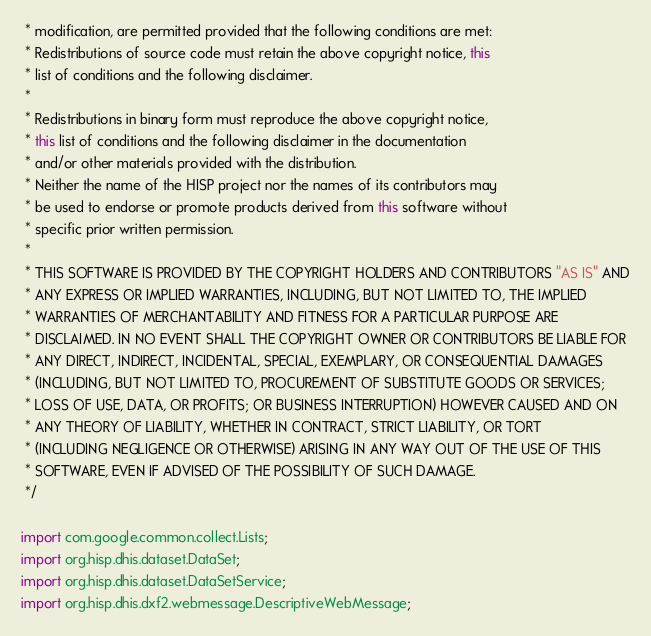<code> <loc_0><loc_0><loc_500><loc_500><_Java_> * modification, are permitted provided that the following conditions are met:
 * Redistributions of source code must retain the above copyright notice, this
 * list of conditions and the following disclaimer.
 *
 * Redistributions in binary form must reproduce the above copyright notice,
 * this list of conditions and the following disclaimer in the documentation
 * and/or other materials provided with the distribution.
 * Neither the name of the HISP project nor the names of its contributors may
 * be used to endorse or promote products derived from this software without
 * specific prior written permission.
 *
 * THIS SOFTWARE IS PROVIDED BY THE COPYRIGHT HOLDERS AND CONTRIBUTORS "AS IS" AND
 * ANY EXPRESS OR IMPLIED WARRANTIES, INCLUDING, BUT NOT LIMITED TO, THE IMPLIED
 * WARRANTIES OF MERCHANTABILITY AND FITNESS FOR A PARTICULAR PURPOSE ARE
 * DISCLAIMED. IN NO EVENT SHALL THE COPYRIGHT OWNER OR CONTRIBUTORS BE LIABLE FOR
 * ANY DIRECT, INDIRECT, INCIDENTAL, SPECIAL, EXEMPLARY, OR CONSEQUENTIAL DAMAGES
 * (INCLUDING, BUT NOT LIMITED TO, PROCUREMENT OF SUBSTITUTE GOODS OR SERVICES;
 * LOSS OF USE, DATA, OR PROFITS; OR BUSINESS INTERRUPTION) HOWEVER CAUSED AND ON
 * ANY THEORY OF LIABILITY, WHETHER IN CONTRACT, STRICT LIABILITY, OR TORT
 * (INCLUDING NEGLIGENCE OR OTHERWISE) ARISING IN ANY WAY OUT OF THE USE OF THIS
 * SOFTWARE, EVEN IF ADVISED OF THE POSSIBILITY OF SUCH DAMAGE.
 */

import com.google.common.collect.Lists;
import org.hisp.dhis.dataset.DataSet;
import org.hisp.dhis.dataset.DataSetService;
import org.hisp.dhis.dxf2.webmessage.DescriptiveWebMessage;</code> 